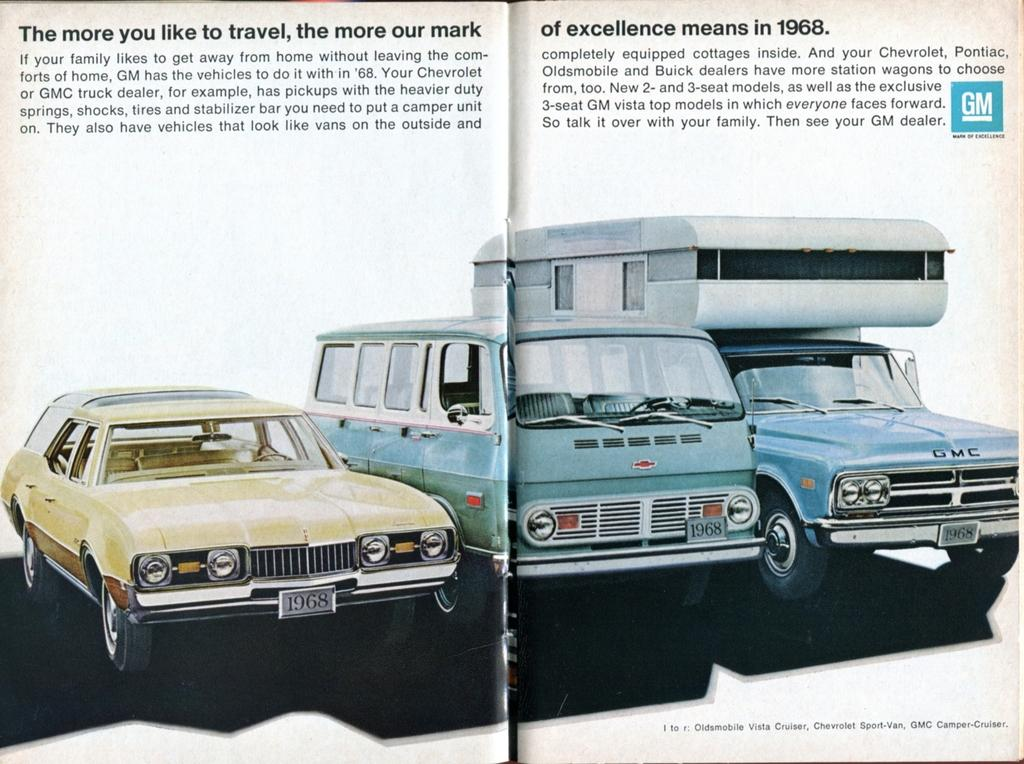<image>
Relay a brief, clear account of the picture shown. A GM ad promotes vehicles available in 1968. 